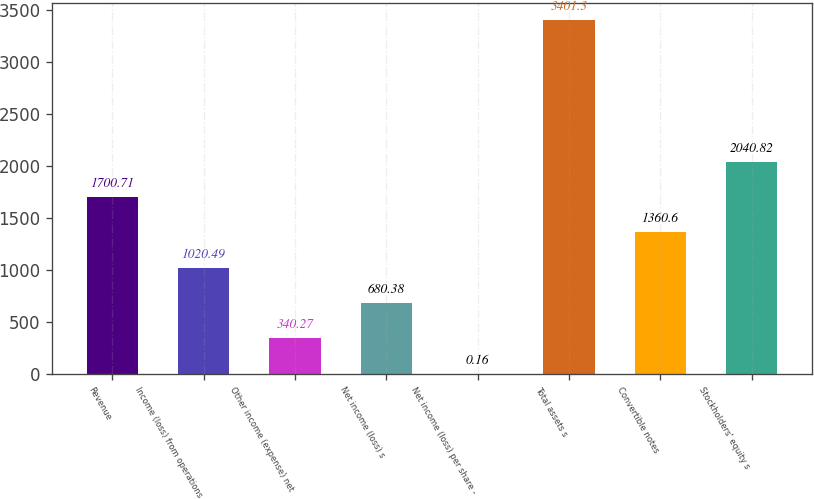Convert chart. <chart><loc_0><loc_0><loc_500><loc_500><bar_chart><fcel>Revenue<fcel>Income (loss) from operations<fcel>Other income (expense) net<fcel>Net income (loss) s<fcel>Net income (loss) per share -<fcel>Total assets s<fcel>Convertible notes<fcel>Stockholders' equity s<nl><fcel>1700.71<fcel>1020.49<fcel>340.27<fcel>680.38<fcel>0.16<fcel>3401.3<fcel>1360.6<fcel>2040.82<nl></chart> 